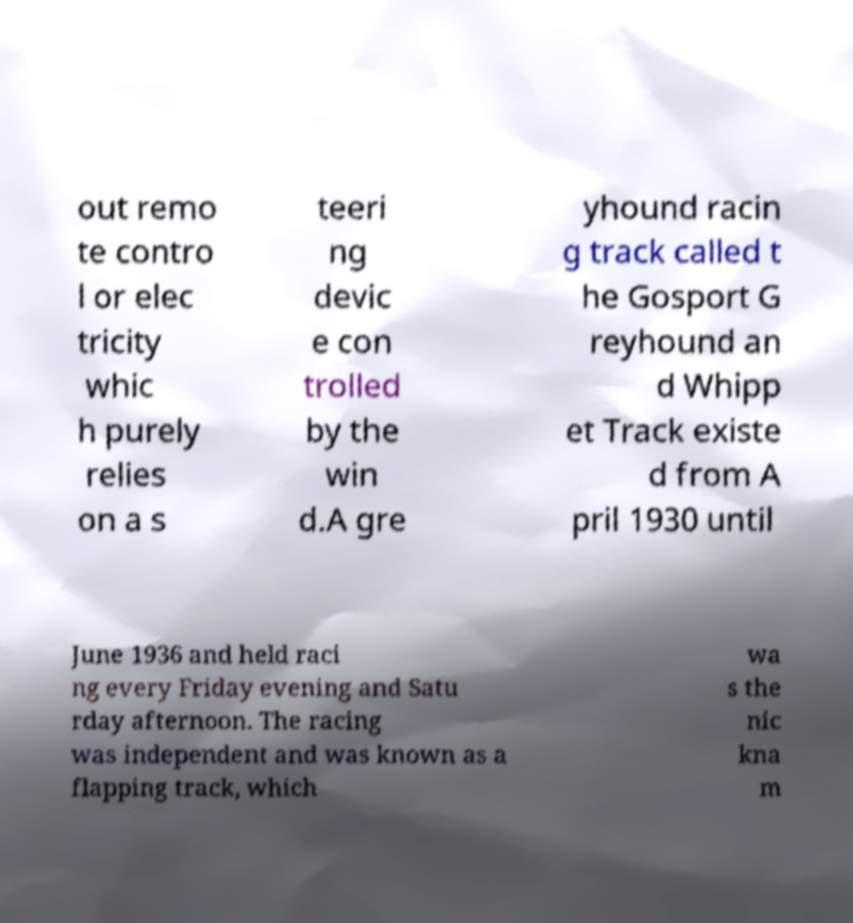Can you read and provide the text displayed in the image?This photo seems to have some interesting text. Can you extract and type it out for me? out remo te contro l or elec tricity whic h purely relies on a s teeri ng devic e con trolled by the win d.A gre yhound racin g track called t he Gosport G reyhound an d Whipp et Track existe d from A pril 1930 until June 1936 and held raci ng every Friday evening and Satu rday afternoon. The racing was independent and was known as a flapping track, which wa s the nic kna m 